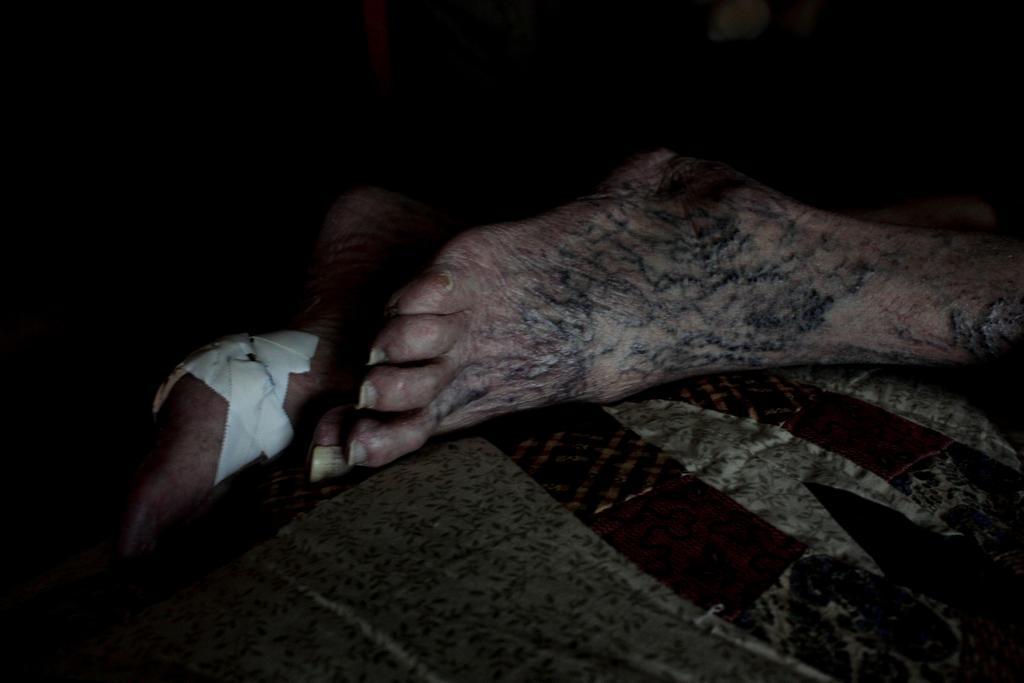How would you summarize this image in a sentence or two? In this image there are legs of the person which is visible. 